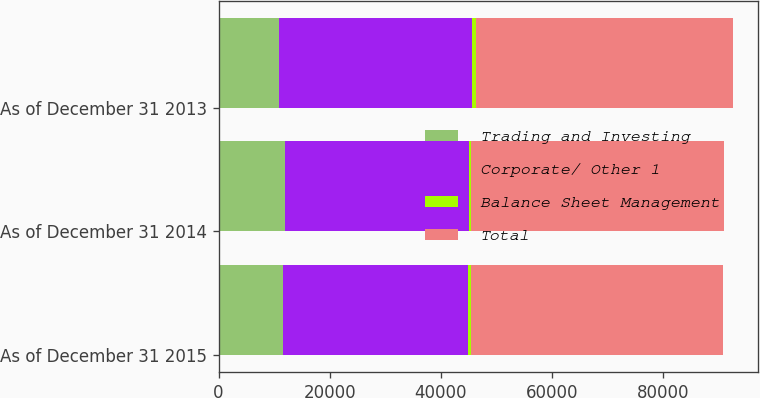Convert chart to OTSL. <chart><loc_0><loc_0><loc_500><loc_500><stacked_bar_chart><ecel><fcel>As of December 31 2015<fcel>As of December 31 2014<fcel>As of December 31 2013<nl><fcel>Trading and Investing<fcel>11554<fcel>12032<fcel>10820<nl><fcel>Corporate/ Other 1<fcel>33278<fcel>33075<fcel>34784<nl><fcel>Balance Sheet Management<fcel>595<fcel>423<fcel>676<nl><fcel>Total<fcel>45427<fcel>45530<fcel>46280<nl></chart> 